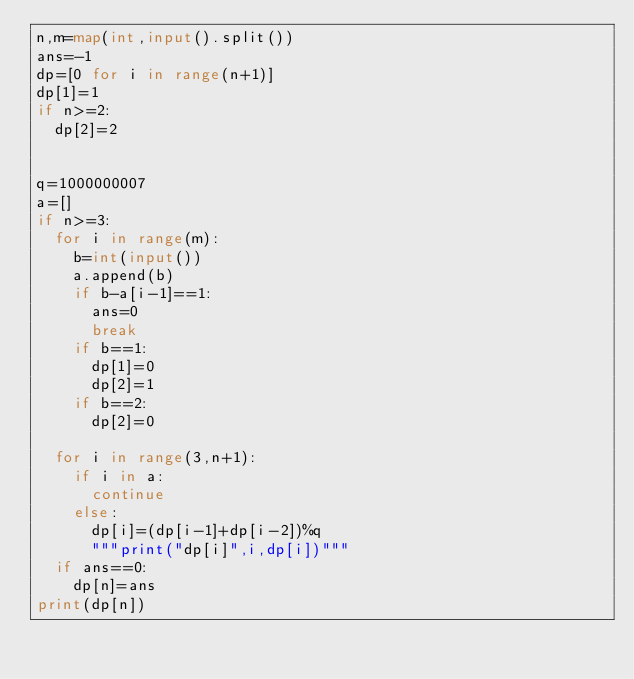<code> <loc_0><loc_0><loc_500><loc_500><_Python_>n,m=map(int,input().split())
ans=-1
dp=[0 for i in range(n+1)]
dp[1]=1
if n>=2:
  dp[2]=2


q=1000000007
a=[]
if n>=3:
  for i in range(m):
    b=int(input())
    a.append(b)
    if b-a[i-1]==1:
      ans=0
      break
    if b==1:
      dp[1]=0
      dp[2]=1
    if b==2:
      dp[2]=0

  for i in range(3,n+1):
    if i in a:
      continue
    else:
      dp[i]=(dp[i-1]+dp[i-2])%q
      """print("dp[i]",i,dp[i])"""
  if ans==0:
    dp[n]=ans
print(dp[n])
</code> 